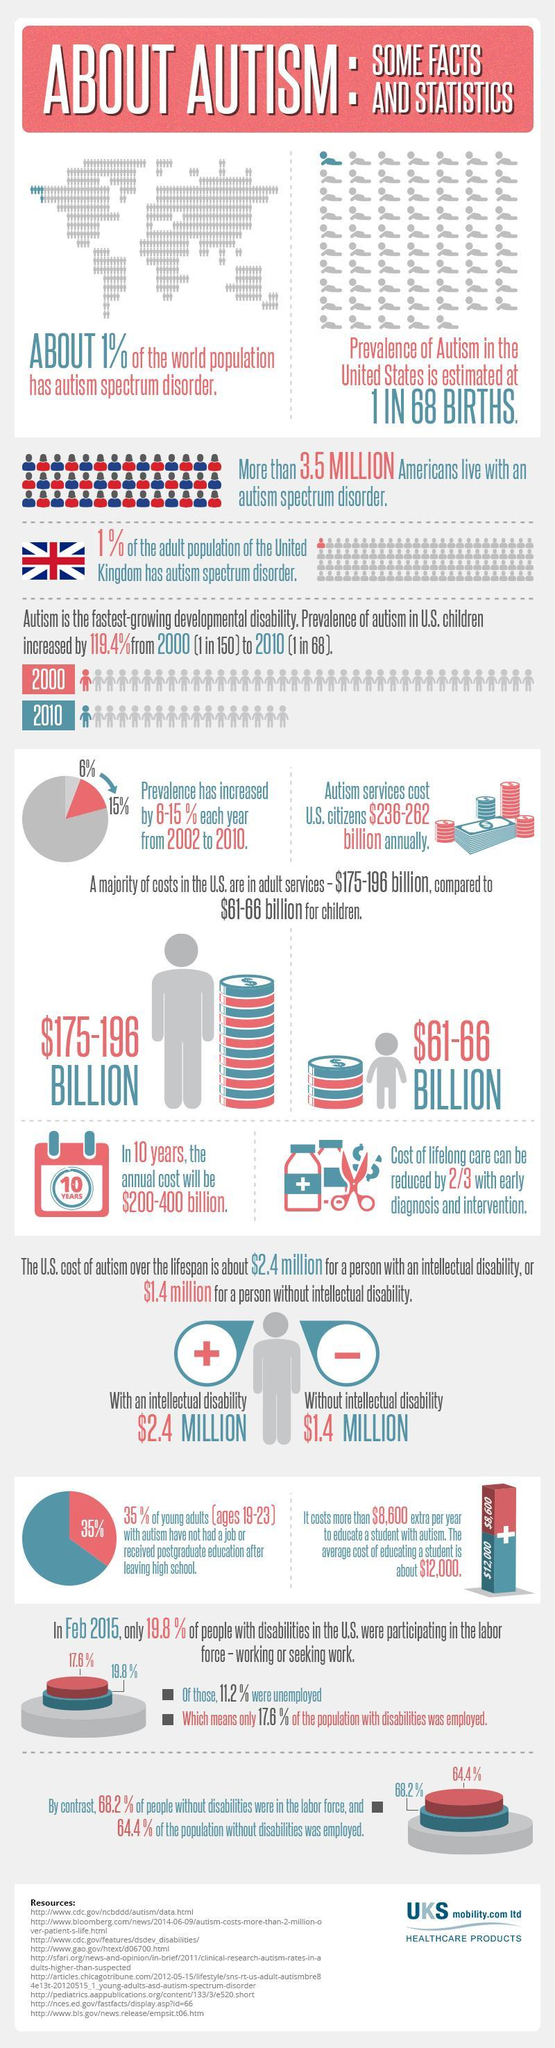What is the percentage difference between population with disabilities who were working and unemployed?
Answer the question with a short phrase. 6.4% What is the percentage difference  between population without disabilities who were working and unemployed? 3.8% 